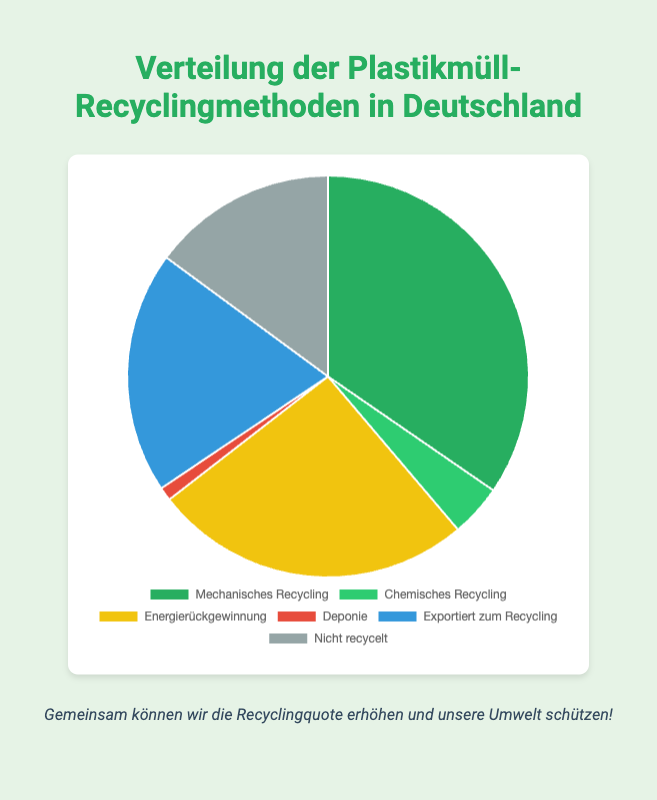What's the total percentage of recycled plastic waste (including mechanical and chemical recycling)? Add the percentage of mechanical recycling (34.6) to chemical recycling (4.2). Thus, 34.6 + 4.2 = 38.8%.
Answer: 38.8% Which recycling method has the highest percentage? According to the chart, the recycling method with the highest percentage is mechanical recycling at 34.6%.
Answer: Mechanical Recycling Which two recycling methods combined account for nearly half of the plastic waste distribution? Mechanical recycling (34.6%) and energy recovery (25.7%) combined sum up to 34.6 + 25.7 = 60.3%, which is over half. Therefore, look at the next highest, excluding mechanical recycling: exported for recycling (19.5%) and energy recovery (25.7%) total 19.5 + 25.7 = 45.2% which is close to half.
Answer: Exported for Recycling and Energy Recovery Which recycling method has the smallest percentage? Referring to the chart, the method with the smallest percentage is landfill at 1.1%.
Answer: Landfill How much higher is the percentage of exported recycling compared to chemical recycling? Subtract chemical recycling (4.2%) from exported for recycling (19.5%). Thus, 19.5 - 4.2 = 15.3%.
Answer: 15.3% What is the percentage difference between mechanical recycling and non-recycled waste? Subtract non-recycled waste (14.9%) from mechanical recycling (34.6%). Thus, 34.6 - 14.9 = 19.7%.
Answer: 19.7% Which segment would be colored green according to the chart? The two green colors are likely representing mechanical recycling (darker green) and chemical recycling (lighter green). Mechanical recycling has the higher percentage and would be the darker green.
Answer: Mechanical Recycling What is the sum of the percentages for landfill, chemical recycling, and non-recycled waste? Add the percentage of landfill (1.1%) to chemical recycling (4.2%) and non-recycled waste (14.9%). Thus, 1.1 + 4.2 + 14.9 = 20.2%.
Answer: 20.2% If we wanted to reduce the non-recycled waste by half, what would its new percentage be? Half of the non-recycled waste percentage (14.9%) would be 14.9 / 2 = 7.45%.
Answer: 7.45% Which recycling method has a little over one-fourth percentage distribution? Referring to the chart, the recycling method closest to one-fourth (25%) and just over it is energy recovery at 25.7%.
Answer: Energy Recovery 